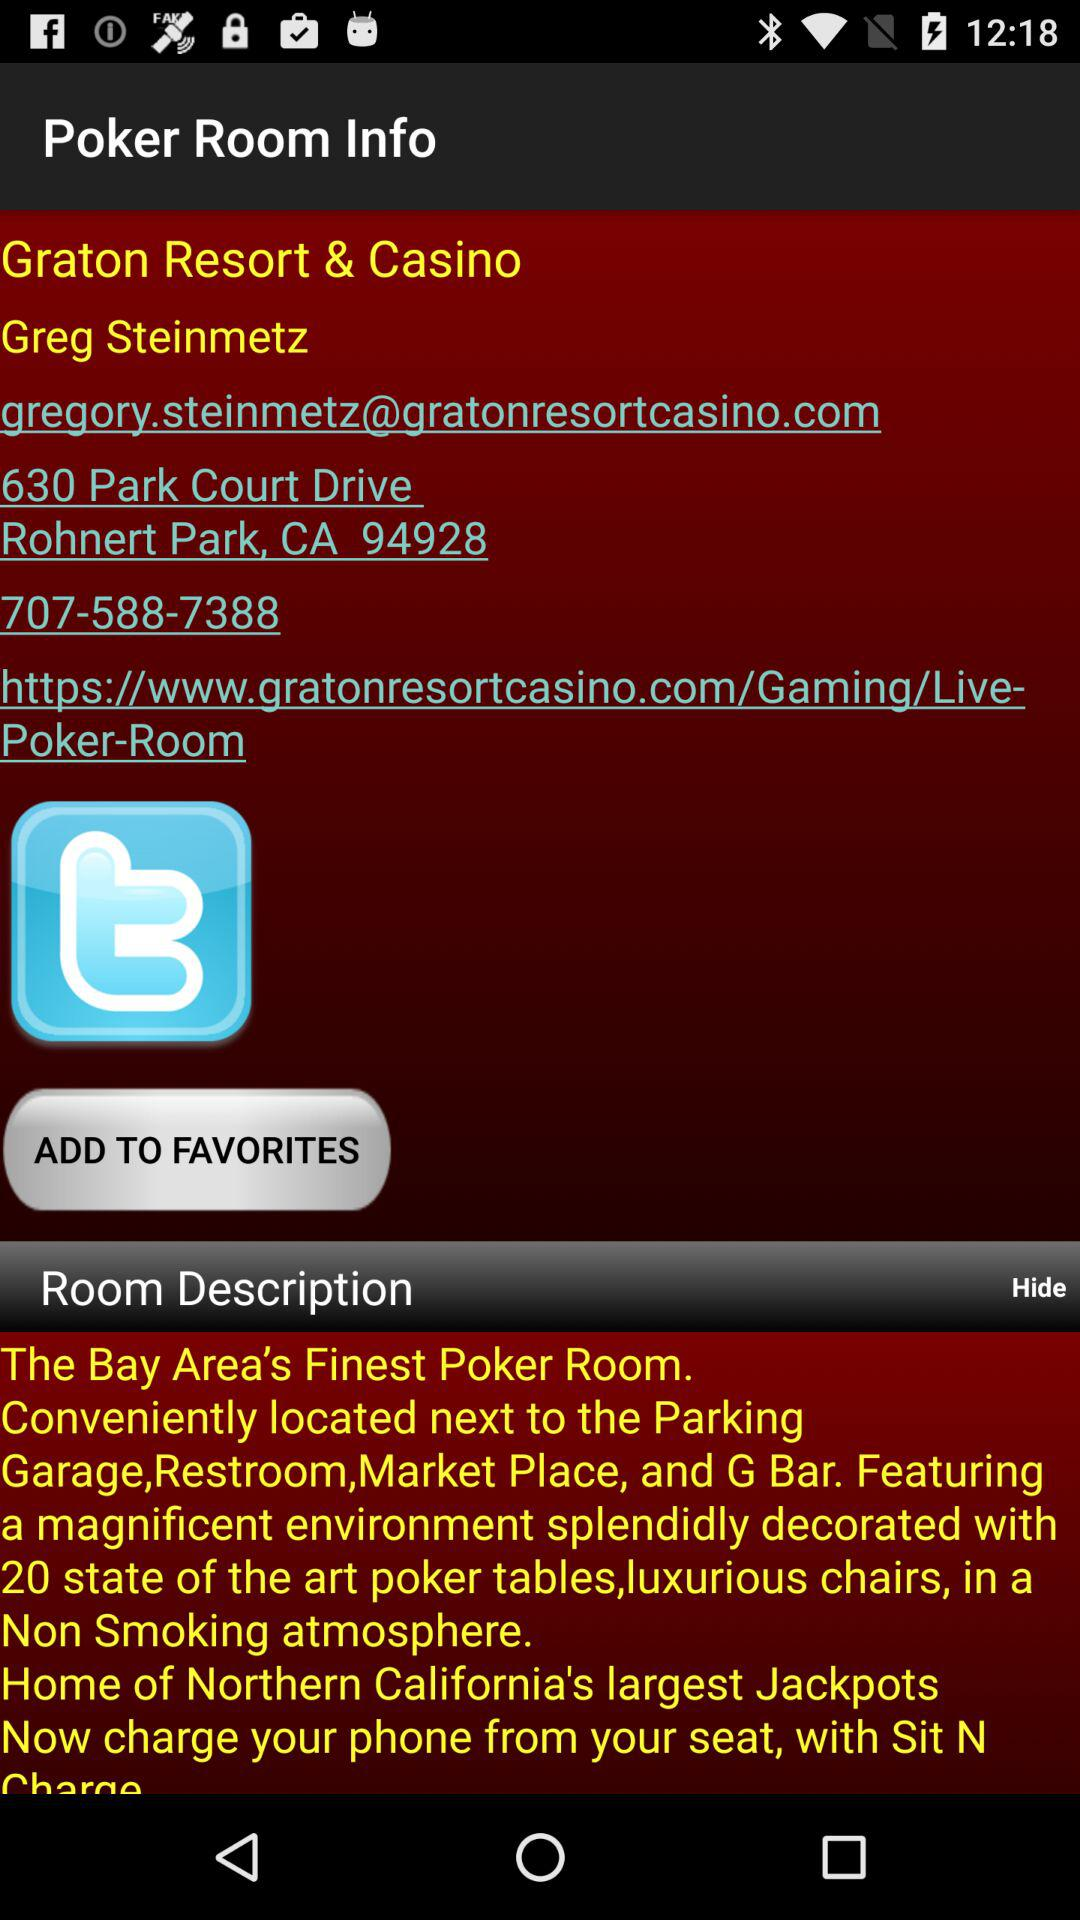What is the phone number? The phone number is 707-588-7388. 